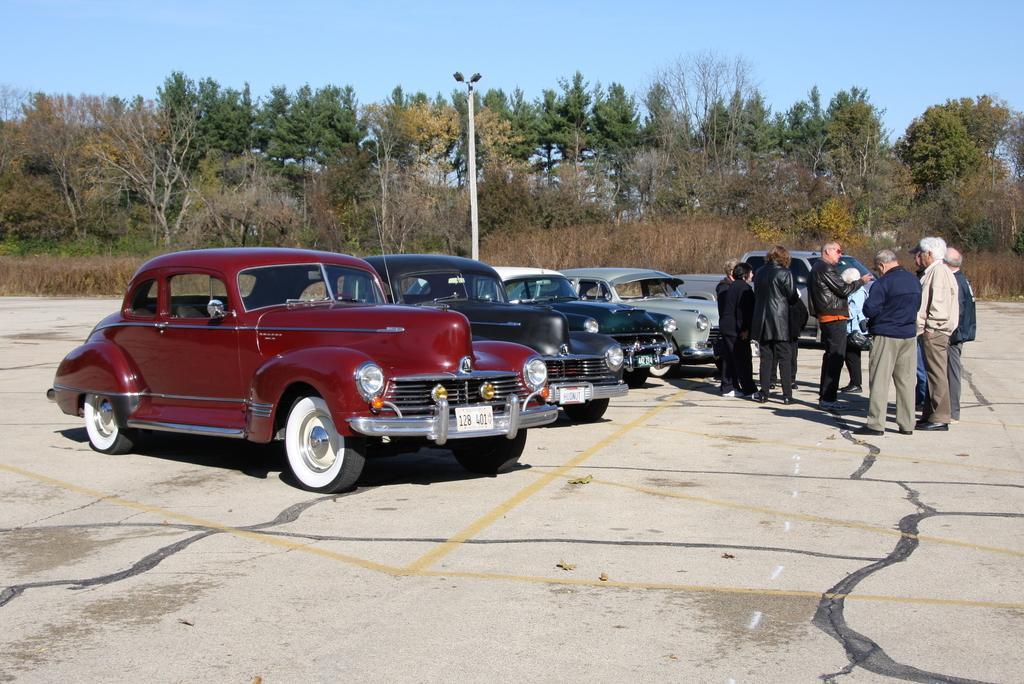In one or two sentences, can you explain what this image depicts? In this image I see 5 cars and I see few persons over here who are standing and I see the path. In the background I see a pole, plants, trees and the sky. 